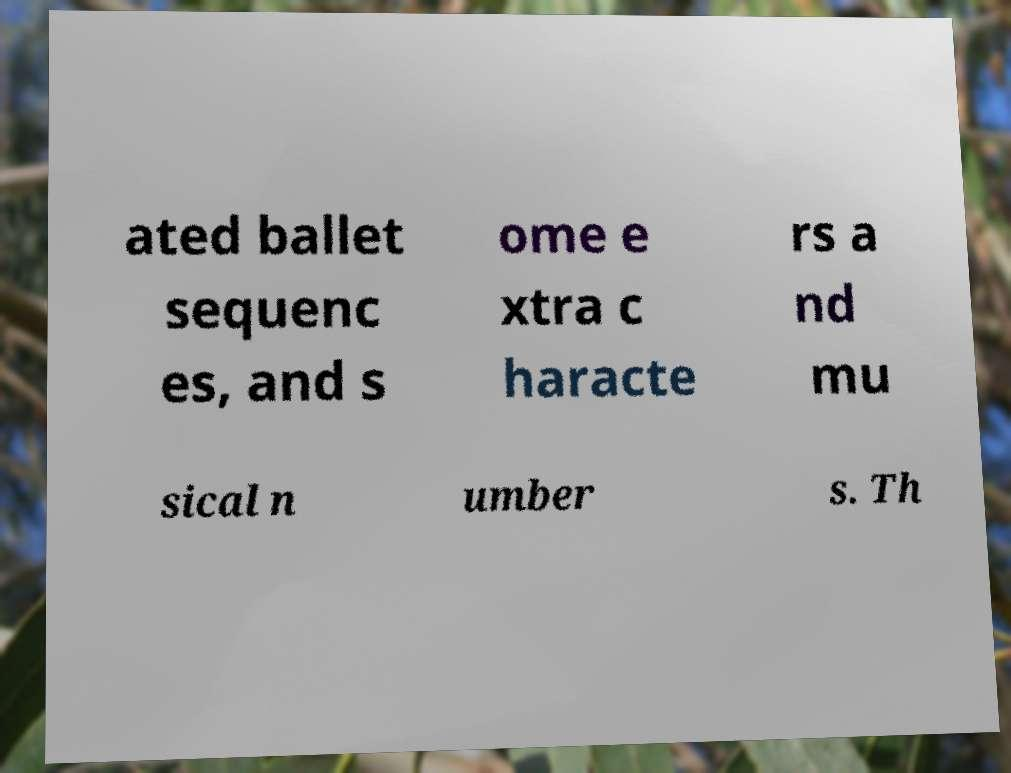Please read and relay the text visible in this image. What does it say? ated ballet sequenc es, and s ome e xtra c haracte rs a nd mu sical n umber s. Th 